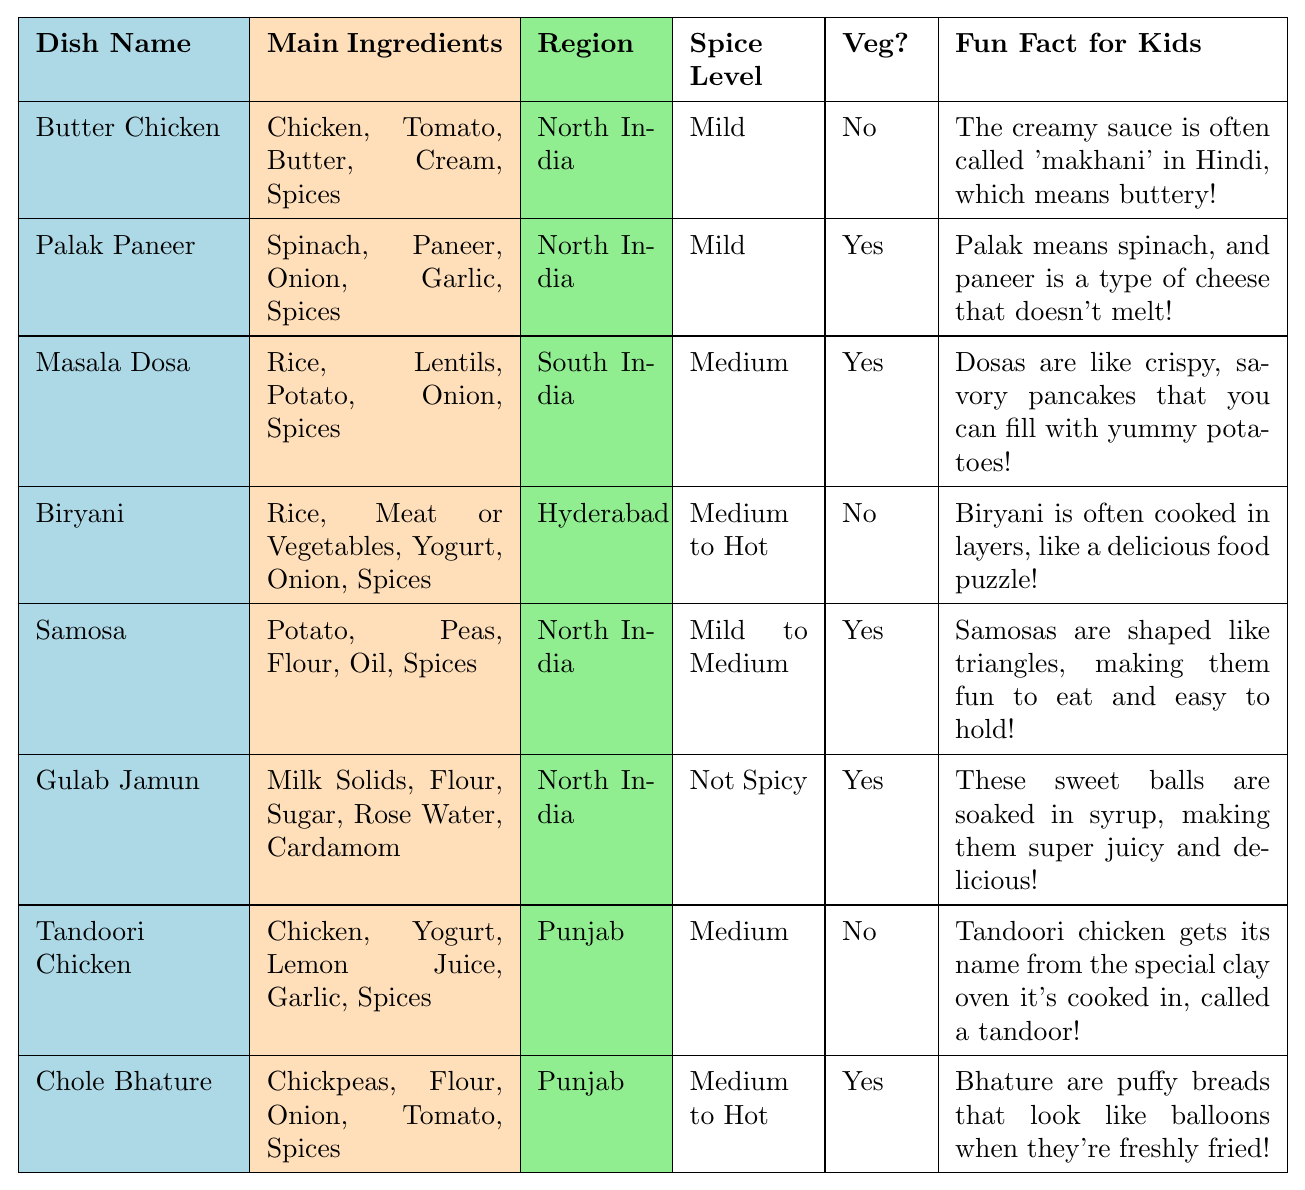What is the main ingredient in Butter Chicken? The table lists "Butter Chicken" and shows its main ingredients as Chicken, Tomato, Butter, Cream, and Spices. The first item is Chicken, so it is the main ingredient.
Answer: Chicken Is Masala Dosa a vegetarian dish? The table indicates that Masala Dosa is categorized under "Vegetarian" with a "Yes" in the Veg? column.
Answer: Yes Which dish has the spice level categorized as "Medium to Hot"? By looking at the spice level column, Biryani and Chole Bhature are marked as "Medium to Hot".
Answer: Biryani and Chole Bhature What region is Gulab Jamun from? The table shows that Gulab Jamun is from North India as indicated in the Region column.
Answer: North India How many dishes are vegetarian? Counting the dishes marked with "Yes" in the Veg? column, we find four vegetarian dishes: Palak Paneer, Masala Dosa, Samosa, and Gulab Jamun.
Answer: Four Which dish uses paneer as an ingredient? The dish Palak Paneer is listed, which has Paneer as one of its main ingredients according to the Main Ingredients column.
Answer: Palak Paneer Is Butter Chicken spicier than Samosa? Butter Chicken has a spice level categorized as "Mild," while Samosa has "Mild to Medium." Therefore, Samosa is spicier.
Answer: No What fun fact is associated with Chole Bhature? The fun fact for Chole Bhature is that "Bhature are puffy breads that look like balloons when they're freshly fried!" as stated in the table.
Answer: Bhature look like balloons when fried Which dish includes rice as an ingredient? By scanning the table, both Biryani and Masala Dosa have Rice included in their main ingredients.
Answer: Biryani and Masala Dosa What dish has the most complex ingredient list? Biryani contains a combination of Rice, Meat or Vegetables, Yogurt, Onion, and Spices, making it among the dishes with more diverse ingredients when compared to others.
Answer: Biryani Which dish is cooked in a tandoor? The table mentions Tandoori Chicken, which is specifically noted to be cooked in a special clay oven called a tandoor.
Answer: Tandoori Chicken Does any dish contain both potatoes and peas? Yes, Samosa contains both Potato and Peas among its main ingredients as listed in the table.
Answer: Yes What is a fun fact about Butter Chicken? The fun fact provided about Butter Chicken is that "The creamy sauce is often called 'makhani' in Hindi, which means buttery!" according to the table.
Answer: The sauce is called 'makhani' Which dish is famous in Hyderabad? The table states that Biryani is specifically associated with Hyderabad in the Region column.
Answer: Biryani Is there a dish on the list with a spice level that is not spicy? The table specifies that Gulab Jamun has a spice level categorized as "Not Spicy," confirming the existence of such a dish.
Answer: Yes 